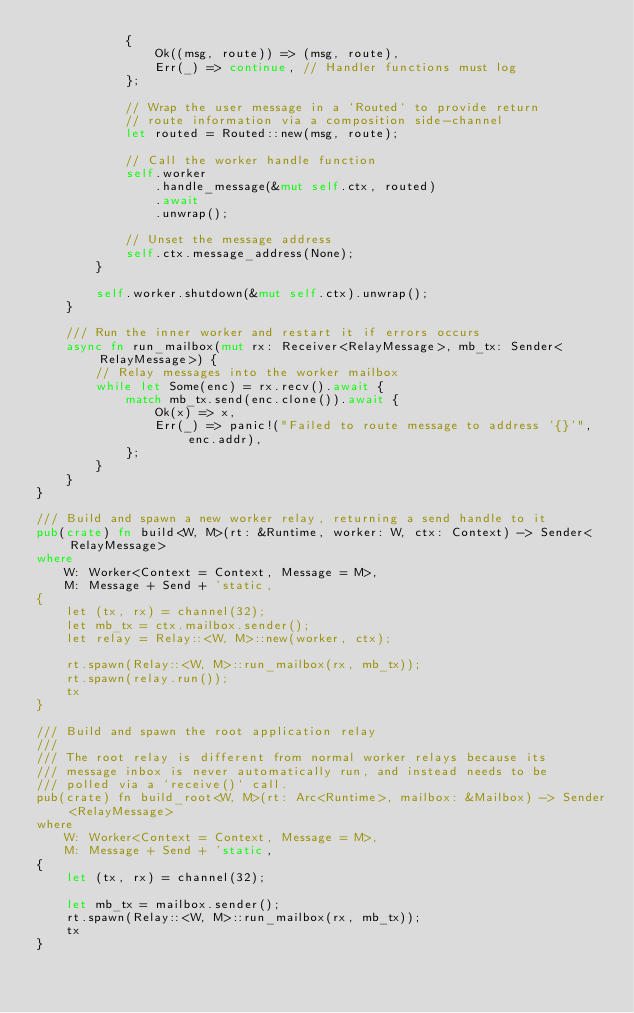Convert code to text. <code><loc_0><loc_0><loc_500><loc_500><_Rust_>            {
                Ok((msg, route)) => (msg, route),
                Err(_) => continue, // Handler functions must log
            };

            // Wrap the user message in a `Routed` to provide return
            // route information via a composition side-channel
            let routed = Routed::new(msg, route);

            // Call the worker handle function
            self.worker
                .handle_message(&mut self.ctx, routed)
                .await
                .unwrap();

            // Unset the message address
            self.ctx.message_address(None);
        }

        self.worker.shutdown(&mut self.ctx).unwrap();
    }

    /// Run the inner worker and restart it if errors occurs
    async fn run_mailbox(mut rx: Receiver<RelayMessage>, mb_tx: Sender<RelayMessage>) {
        // Relay messages into the worker mailbox
        while let Some(enc) = rx.recv().await {
            match mb_tx.send(enc.clone()).await {
                Ok(x) => x,
                Err(_) => panic!("Failed to route message to address '{}'", enc.addr),
            };
        }
    }
}

/// Build and spawn a new worker relay, returning a send handle to it
pub(crate) fn build<W, M>(rt: &Runtime, worker: W, ctx: Context) -> Sender<RelayMessage>
where
    W: Worker<Context = Context, Message = M>,
    M: Message + Send + 'static,
{
    let (tx, rx) = channel(32);
    let mb_tx = ctx.mailbox.sender();
    let relay = Relay::<W, M>::new(worker, ctx);

    rt.spawn(Relay::<W, M>::run_mailbox(rx, mb_tx));
    rt.spawn(relay.run());
    tx
}

/// Build and spawn the root application relay
///
/// The root relay is different from normal worker relays because its
/// message inbox is never automatically run, and instead needs to be
/// polled via a `receive()` call.
pub(crate) fn build_root<W, M>(rt: Arc<Runtime>, mailbox: &Mailbox) -> Sender<RelayMessage>
where
    W: Worker<Context = Context, Message = M>,
    M: Message + Send + 'static,
{
    let (tx, rx) = channel(32);

    let mb_tx = mailbox.sender();
    rt.spawn(Relay::<W, M>::run_mailbox(rx, mb_tx));
    tx
}
</code> 